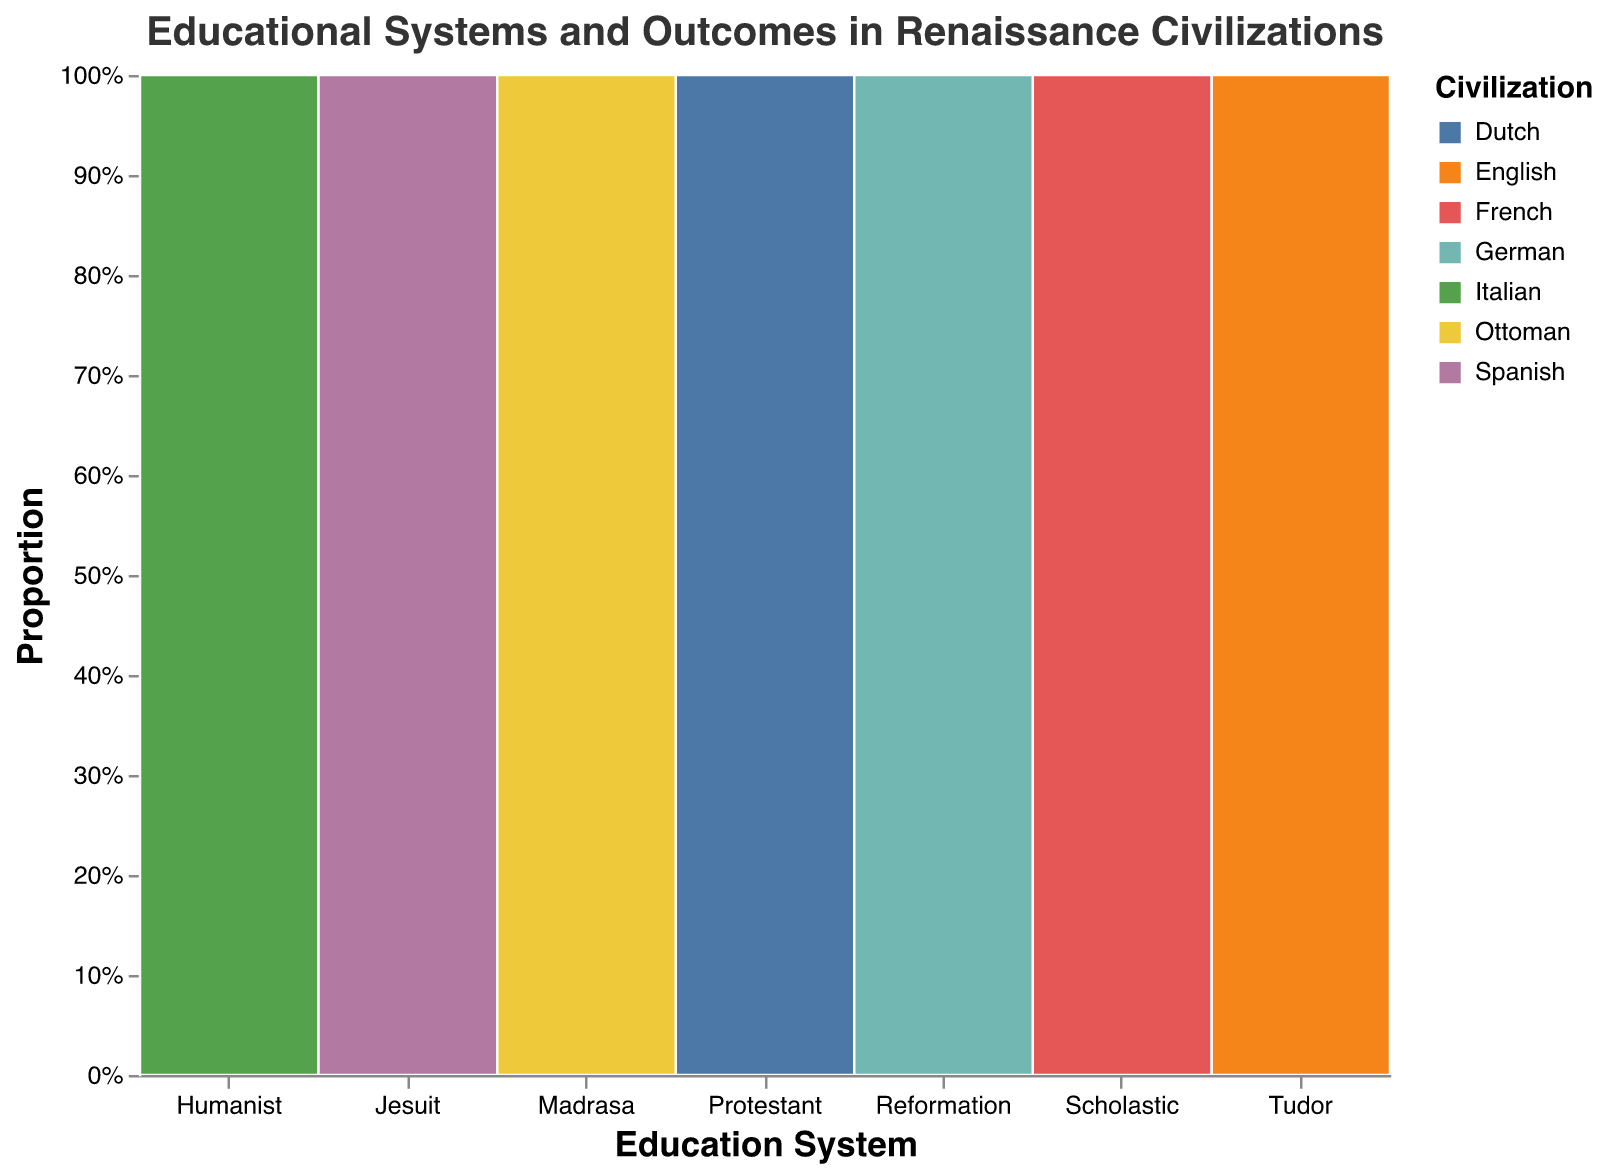What is the title of the figure? The title of the figure is located at the top and reads "Educational Systems and Outcomes in Renaissance Civilizations" in a 16-point Helvetica font.
Answer: Educational Systems and Outcomes in Renaissance Civilizations Which civilization has the highest literacy rate? The civilization with the highest literacy rate, represented by the percentage in the data, is displayed under the "Literacy Rate" category. The Italian civilization has a literacy rate of 65%.
Answer: Italian How many civilizations have a university attendance rate of above 10%? Examining the values plotted under "University Attendance", only three civilizations (Italian, French, and Dutch) have a university attendance rate above 10%.
Answer: 3 What is the proportion of literacy rate for the German civilization in comparison to the French and Ottoman civilizations? The German civilization has a literacy rate of 50%, the French have 40%, and the Ottomans have 30%. This involves a comparison of three values.
Answer: German (50%) > French (40%) > Ottoman (30%) Which educational system does the Dutch civilization follow? The educational system followed by the Dutch civilization is mentioned next to their data point in the “Education System” category. The Dutch use the “Protestant” system.
Answer: Protestant Which civilization has the lowest university attendance rate, and what is it? By examining the "University Attendance" values in the plot, the Ottoman civilization has the lowest attendance rate of 5%.
Answer: Ottoman, 5% Among the civilizations with a university attendance rate above 10%, which one has the lowest literacy rate? First, identify the civilizations with university attendance above 10% (Italian, Dutch, German) and then compare their literacy rates (65%, 55%, 50% respectively), revealing the German civilization as the lowest.
Answer: German What proportion does the English civilization represent in the Tudor education system category? Using the Mosaic plot data transformation, the English proportion in the Tudor category is their counted value over the total in the "Education System," which is obtained from the "percentage" encoding.
Answer: Derived from the data processing, but specific to visual plot percentages Based on the plot, which notable figure corresponds to the Spanish civilization? Notable figures are paired with each civilization directly in the data provided. For the Spanish civilization, Miguel de Cervantes is the notable figure.
Answer: Miguel de Cervantes 